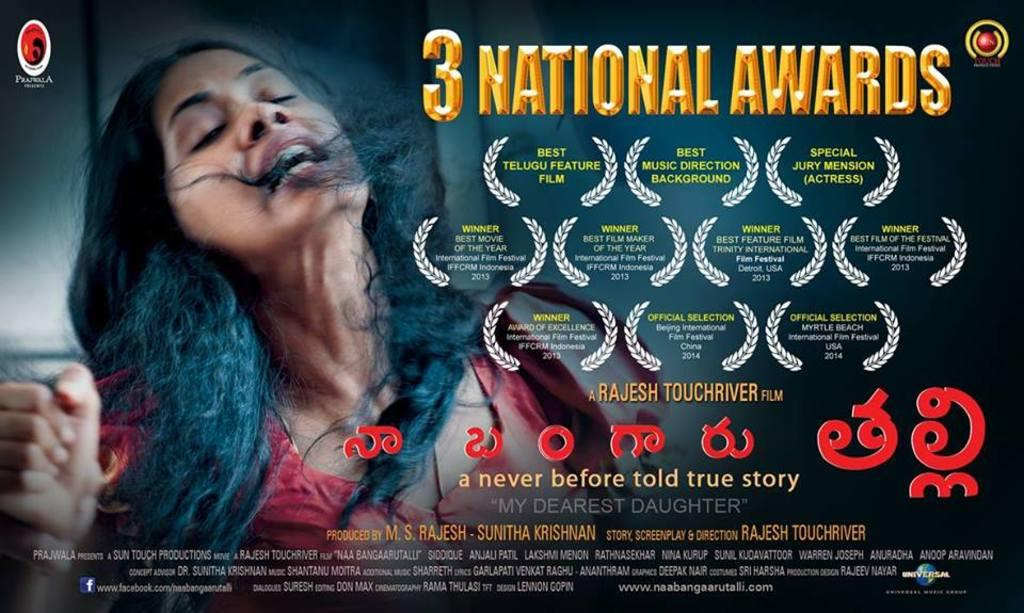Provide a one-sentence caption for the provided image. An advertisement for a movie that won 3 national awards. 